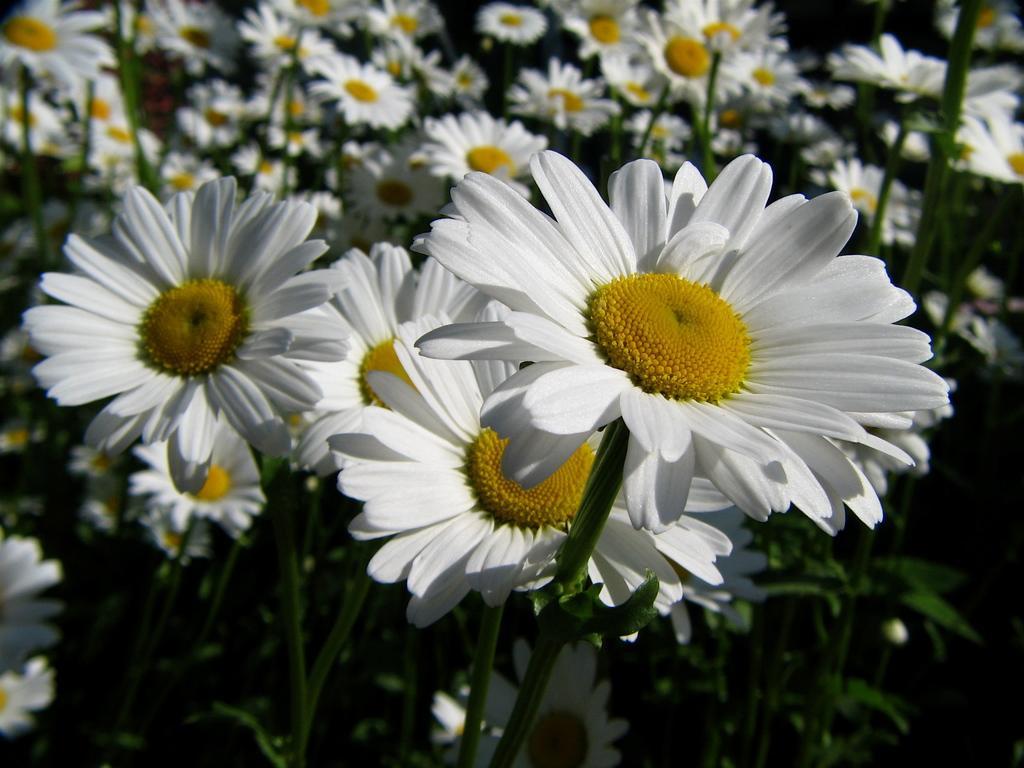Describe this image in one or two sentences. In this image I can see flowers, stems, leaves. 